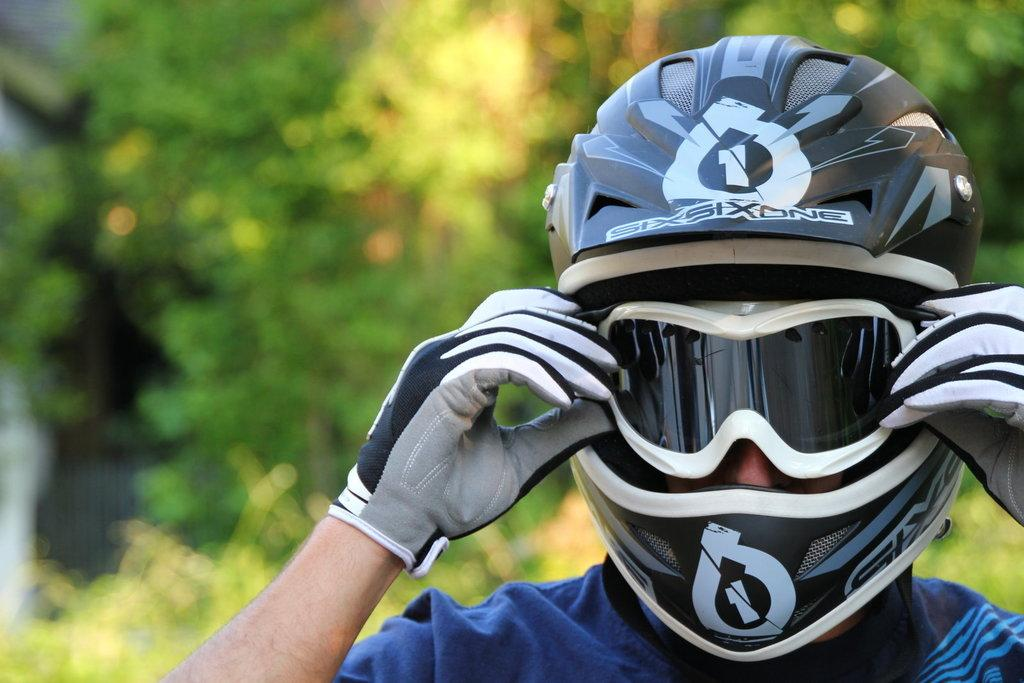Who is present in the image? There is a person in the image. What accessories is the person wearing? The person is wearing glasses, a helmet, and gloves. What can be seen in the background of the image? There is a group of trees visible in the background of the image. What scientific experiment is being conducted in the image? There is no scientific experiment visible in the image. What color is the sky in the image? The provided facts do not mention the color of the sky, so it cannot be determined from the image. 